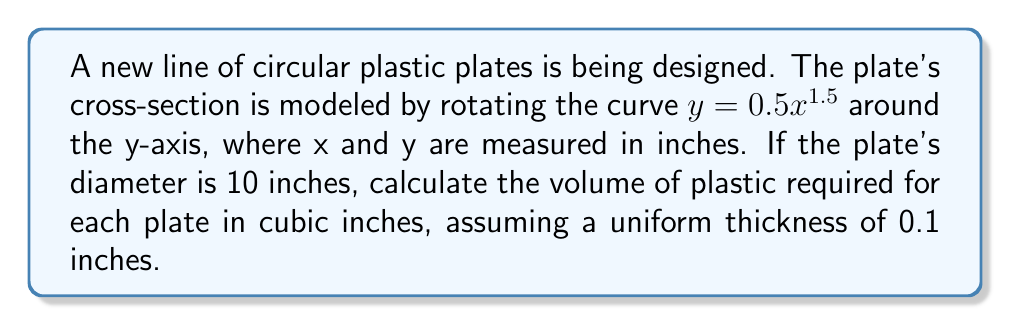What is the answer to this math problem? To solve this problem, we'll use the method of cylindrical shells to calculate the volume of revolution and then add the volume of the flat bottom.

Step 1: Set up the integral for the volume of revolution
The volume of a cylindrical shell is given by $V = 2\pi r h dr$, where r is the radius and h is the height of the shell.
In our case, $r = x$ and $h = 0.5x^{1.5}$

The integral will be:
$$V = 2\pi \int_0^5 x(0.5x^{1.5})dx$$

Step 2: Evaluate the integral
$$\begin{align}
V &= 2\pi \int_0^5 0.5x^{2.5}dx \\
&= \pi \int_0^5 x^{2.5}dx \\
&= \pi \left[\frac{x^{3.5}}{3.5}\right]_0^5 \\
&= \pi \left(\frac{5^{3.5}}{3.5} - 0\right) \\
&= \frac{\pi}{3.5} \cdot 5^{3.5} \\
&\approx 49.87 \text{ cubic inches}
\end{align}$$

Step 3: Calculate the volume of the flat bottom
The volume of the flat bottom is the area of the circle multiplied by the thickness:
$$V_{bottom} = \pi r^2 \cdot 0.1 = \pi \cdot 5^2 \cdot 0.1 \approx 7.85 \text{ cubic inches}$$

Step 4: Sum the volumes
Total volume = Volume of revolution + Volume of flat bottom
$$V_{total} = 49.87 + 7.85 = 57.72 \text{ cubic inches}$$
Answer: 57.72 cubic inches 